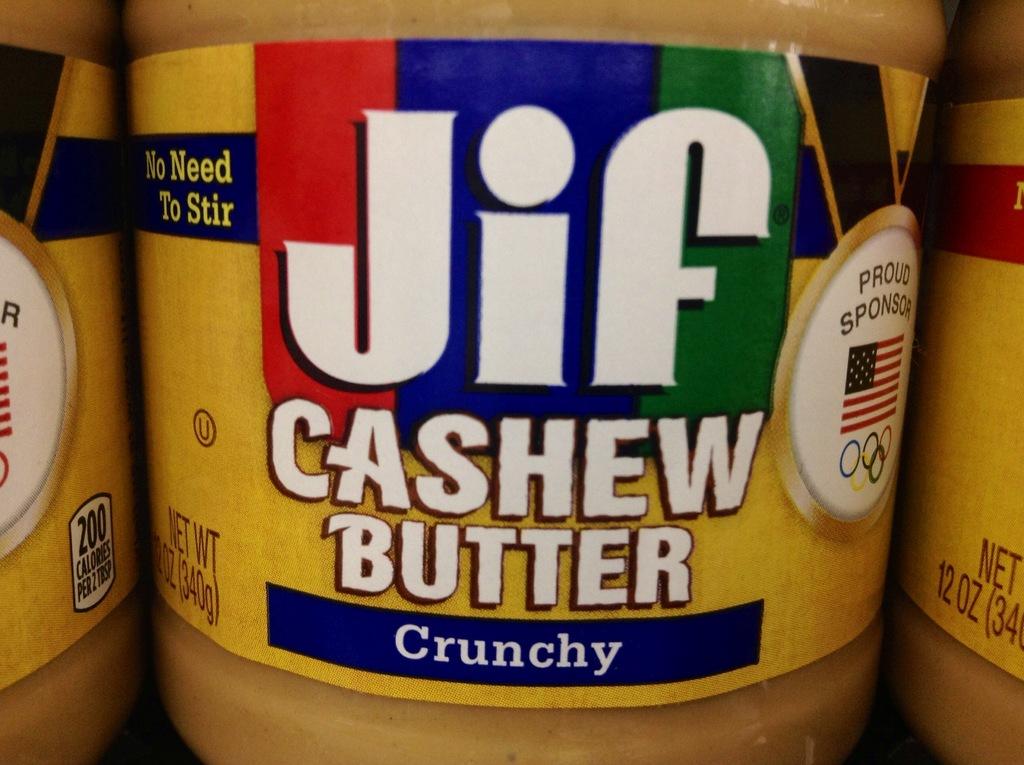What is this brand of peanut butter?
Provide a short and direct response. Jif. 